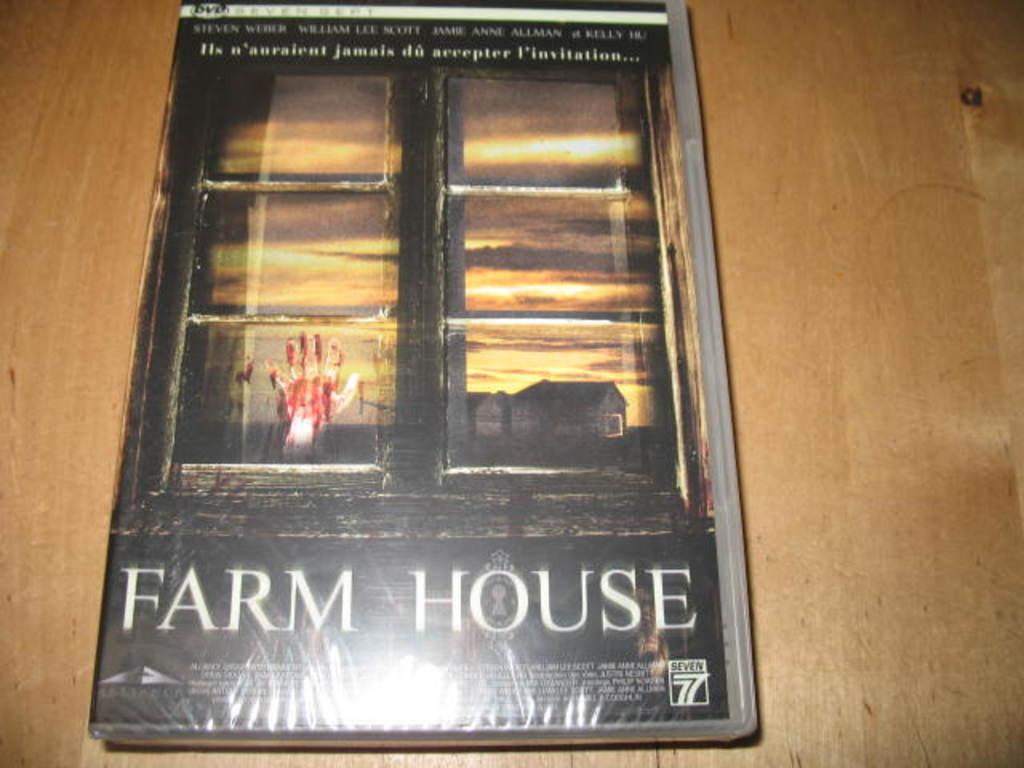<image>
Describe the image concisely. A book covered in clear plastic has the title Farm House and the image of a bloody hand on a window pane. 